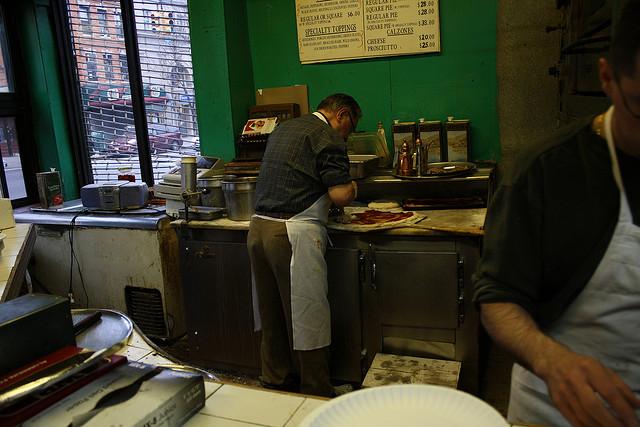What are the men wearing over their shirts and trousers?
Concise answer only. Aprons. What color is the wall in the kitchen?
Answer briefly. Green. Is this a restaurant kitchen?
Concise answer only. Yes. 